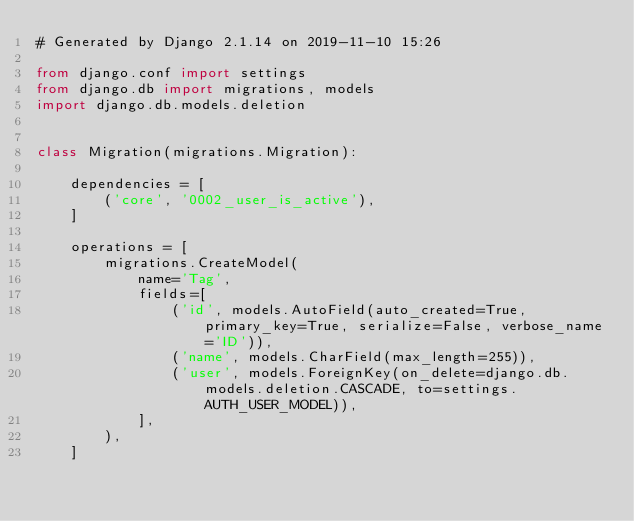Convert code to text. <code><loc_0><loc_0><loc_500><loc_500><_Python_># Generated by Django 2.1.14 on 2019-11-10 15:26

from django.conf import settings
from django.db import migrations, models
import django.db.models.deletion


class Migration(migrations.Migration):

    dependencies = [
        ('core', '0002_user_is_active'),
    ]

    operations = [
        migrations.CreateModel(
            name='Tag',
            fields=[
                ('id', models.AutoField(auto_created=True, primary_key=True, serialize=False, verbose_name='ID')),
                ('name', models.CharField(max_length=255)),
                ('user', models.ForeignKey(on_delete=django.db.models.deletion.CASCADE, to=settings.AUTH_USER_MODEL)),
            ],
        ),
    ]
</code> 